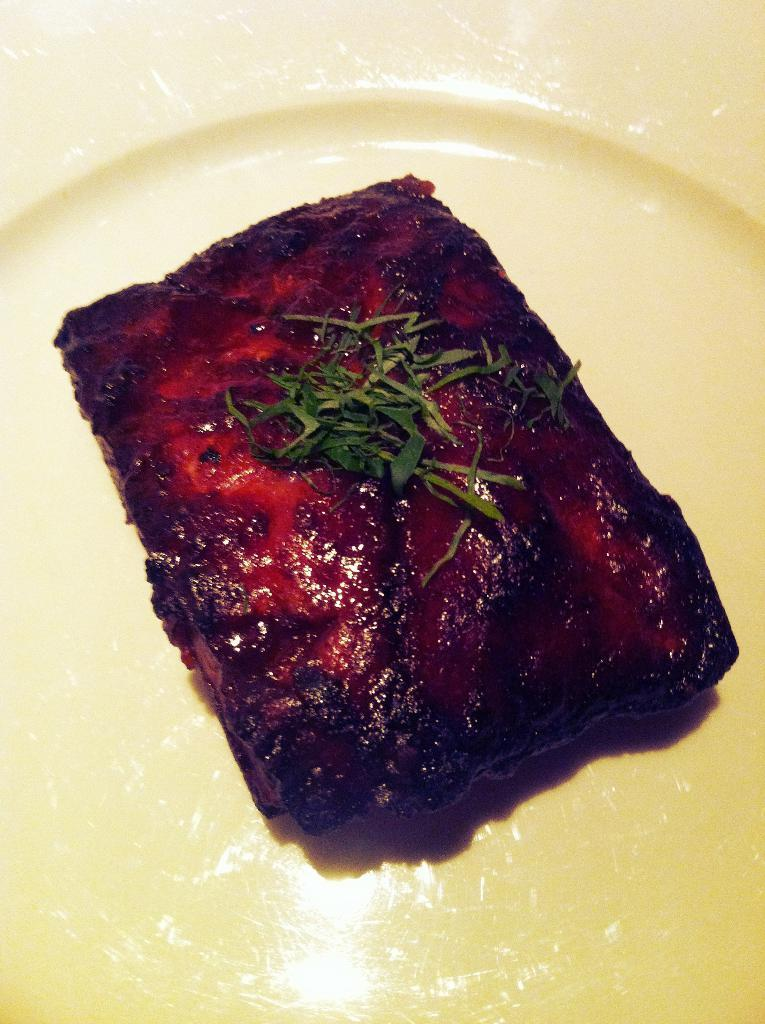What is the focus of the image? The image is a zoomed in picture. What can be seen in the foreground of the image? There is a platter in the foreground of the image. What is on the platter? The platter contains food items. Is there a fan blowing on the food items in the image? There is no fan present in the image, so it cannot be determined if it is blowing on the food items. 